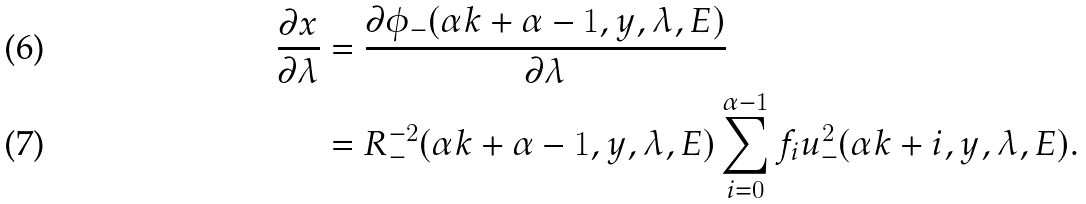Convert formula to latex. <formula><loc_0><loc_0><loc_500><loc_500>\frac { \partial x } { \partial \lambda } & = \frac { \partial \phi _ { - } ( \alpha k + \alpha - 1 , y , \lambda , E ) } { \partial \lambda } \\ & = R _ { - } ^ { - 2 } ( \alpha k + \alpha - 1 , y , \lambda , E ) \sum _ { i = 0 } ^ { \alpha - 1 } f _ { i } u _ { - } ^ { 2 } ( \alpha k + i , y , \lambda , E ) .</formula> 